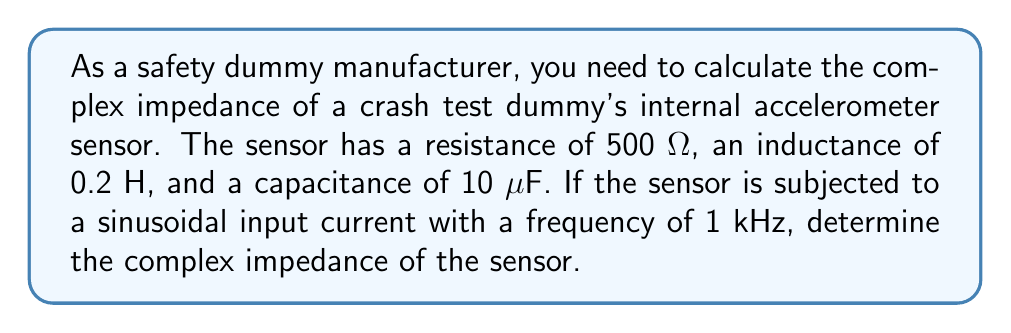Could you help me with this problem? To calculate the complex impedance of the crash test dummy's internal sensor, we need to consider the resistive, inductive, and capacitive components. The complex impedance is given by the formula:

$$Z = R + j(X_L - X_C)$$

Where:
$Z$ is the complex impedance
$R$ is the resistance
$X_L$ is the inductive reactance
$X_C$ is the capacitive reactance
$j$ is the imaginary unit

Step 1: Calculate the angular frequency ω
$$\omega = 2\pi f = 2\pi \cdot 1000 = 2000\pi \text{ rad/s}$$

Step 2: Calculate the inductive reactance $X_L$
$$X_L = \omega L = 2000\pi \cdot 0.2 = 400\pi \text{ Ω}$$

Step 3: Calculate the capacitive reactance $X_C$
$$X_C = \frac{1}{\omega C} = \frac{1}{2000\pi \cdot 10 \cdot 10^{-6}} = \frac{50000}{\pi} \text{ Ω}$$

Step 4: Substitute the values into the complex impedance formula
$$Z = 500 + j(400\pi - \frac{50000}{\pi})$$

Step 5: Simplify the imaginary part
$$Z = 500 + j(1256.64 - 15915.49) = 500 - j14658.85 \text{ Ω}$$

Therefore, the complex impedance of the crash test dummy's internal sensor is 500 - j14658.85 Ω.
Answer: $Z = 500 - j14658.85 \text{ Ω}$ 